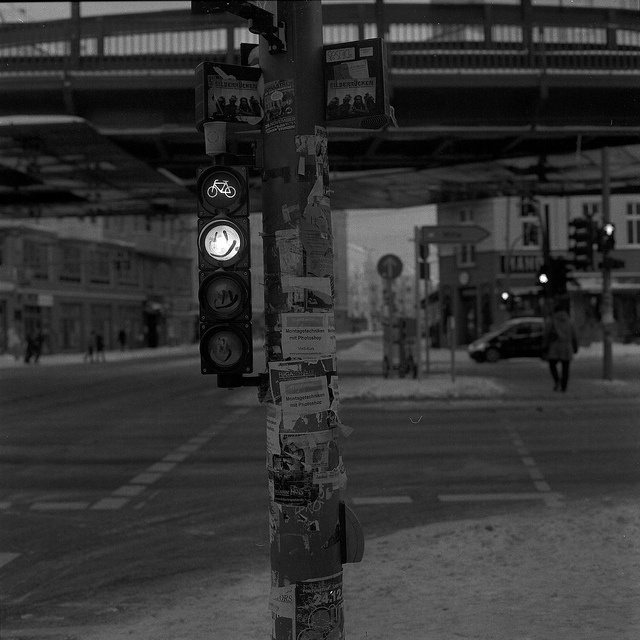Describe the objects in this image and their specific colors. I can see traffic light in black, lightgray, gray, and darkgray tones, car in black and gray tones, people in black tones, traffic light in black tones, and traffic light in black tones in this image. 